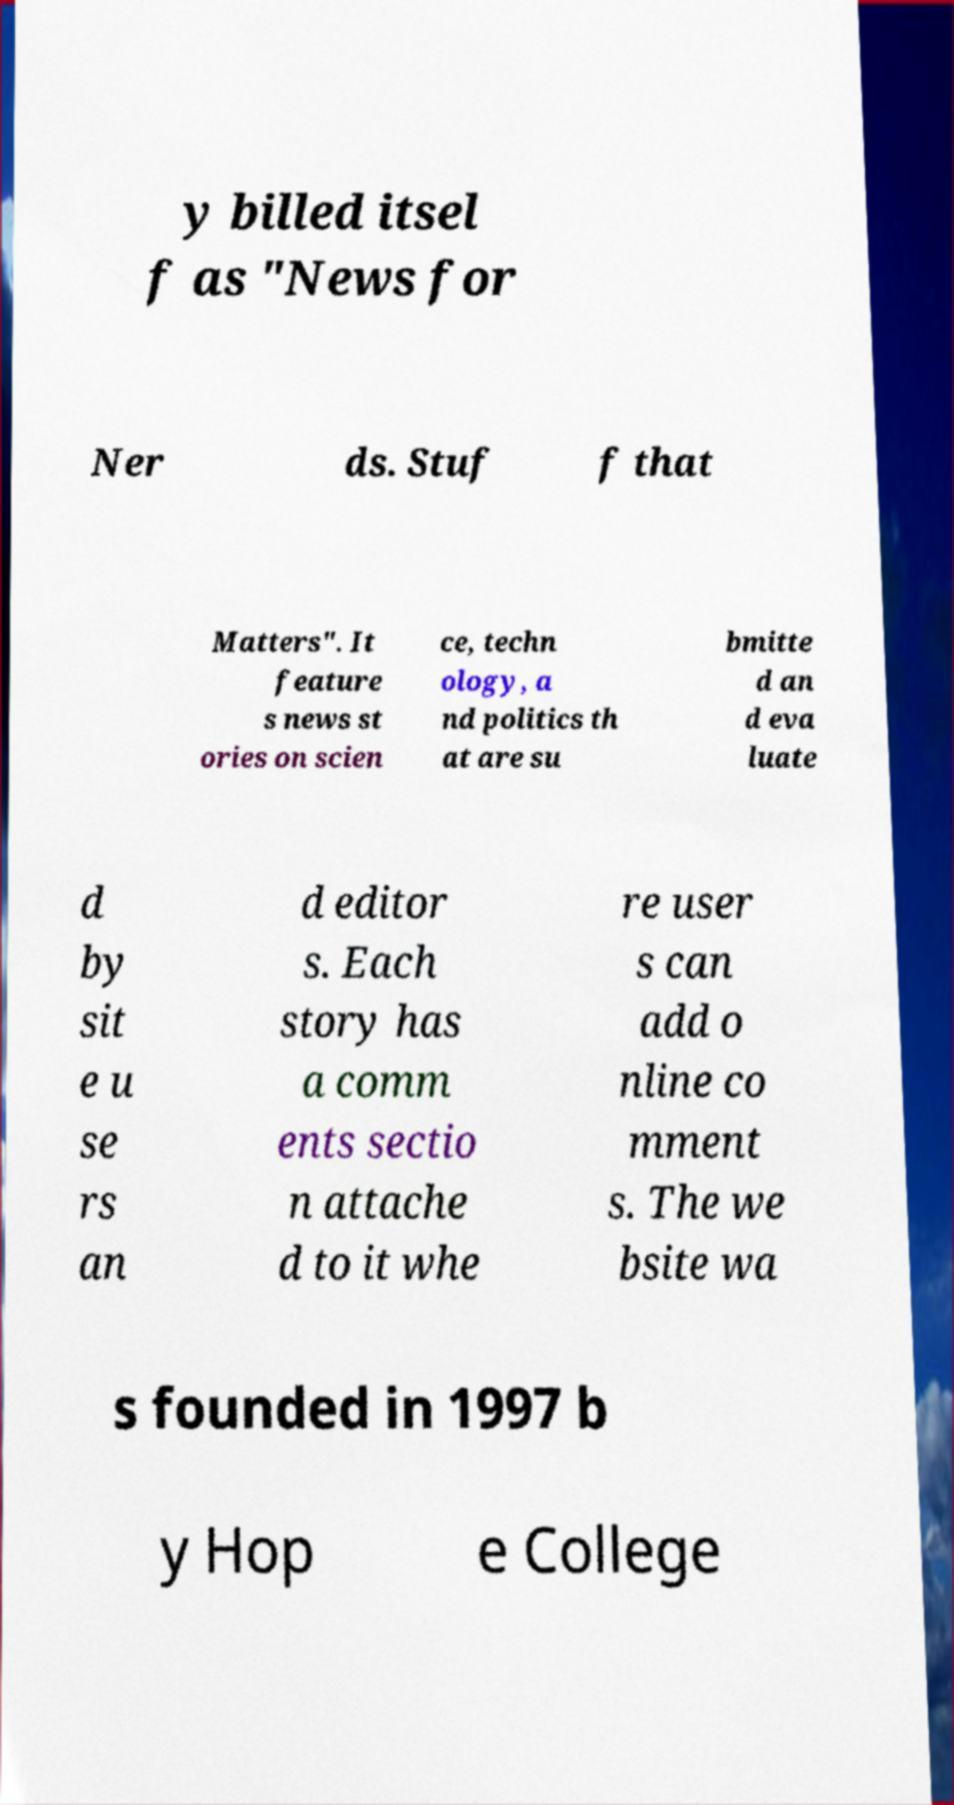Can you read and provide the text displayed in the image?This photo seems to have some interesting text. Can you extract and type it out for me? y billed itsel f as "News for Ner ds. Stuf f that Matters". It feature s news st ories on scien ce, techn ology, a nd politics th at are su bmitte d an d eva luate d by sit e u se rs an d editor s. Each story has a comm ents sectio n attache d to it whe re user s can add o nline co mment s. The we bsite wa s founded in 1997 b y Hop e College 